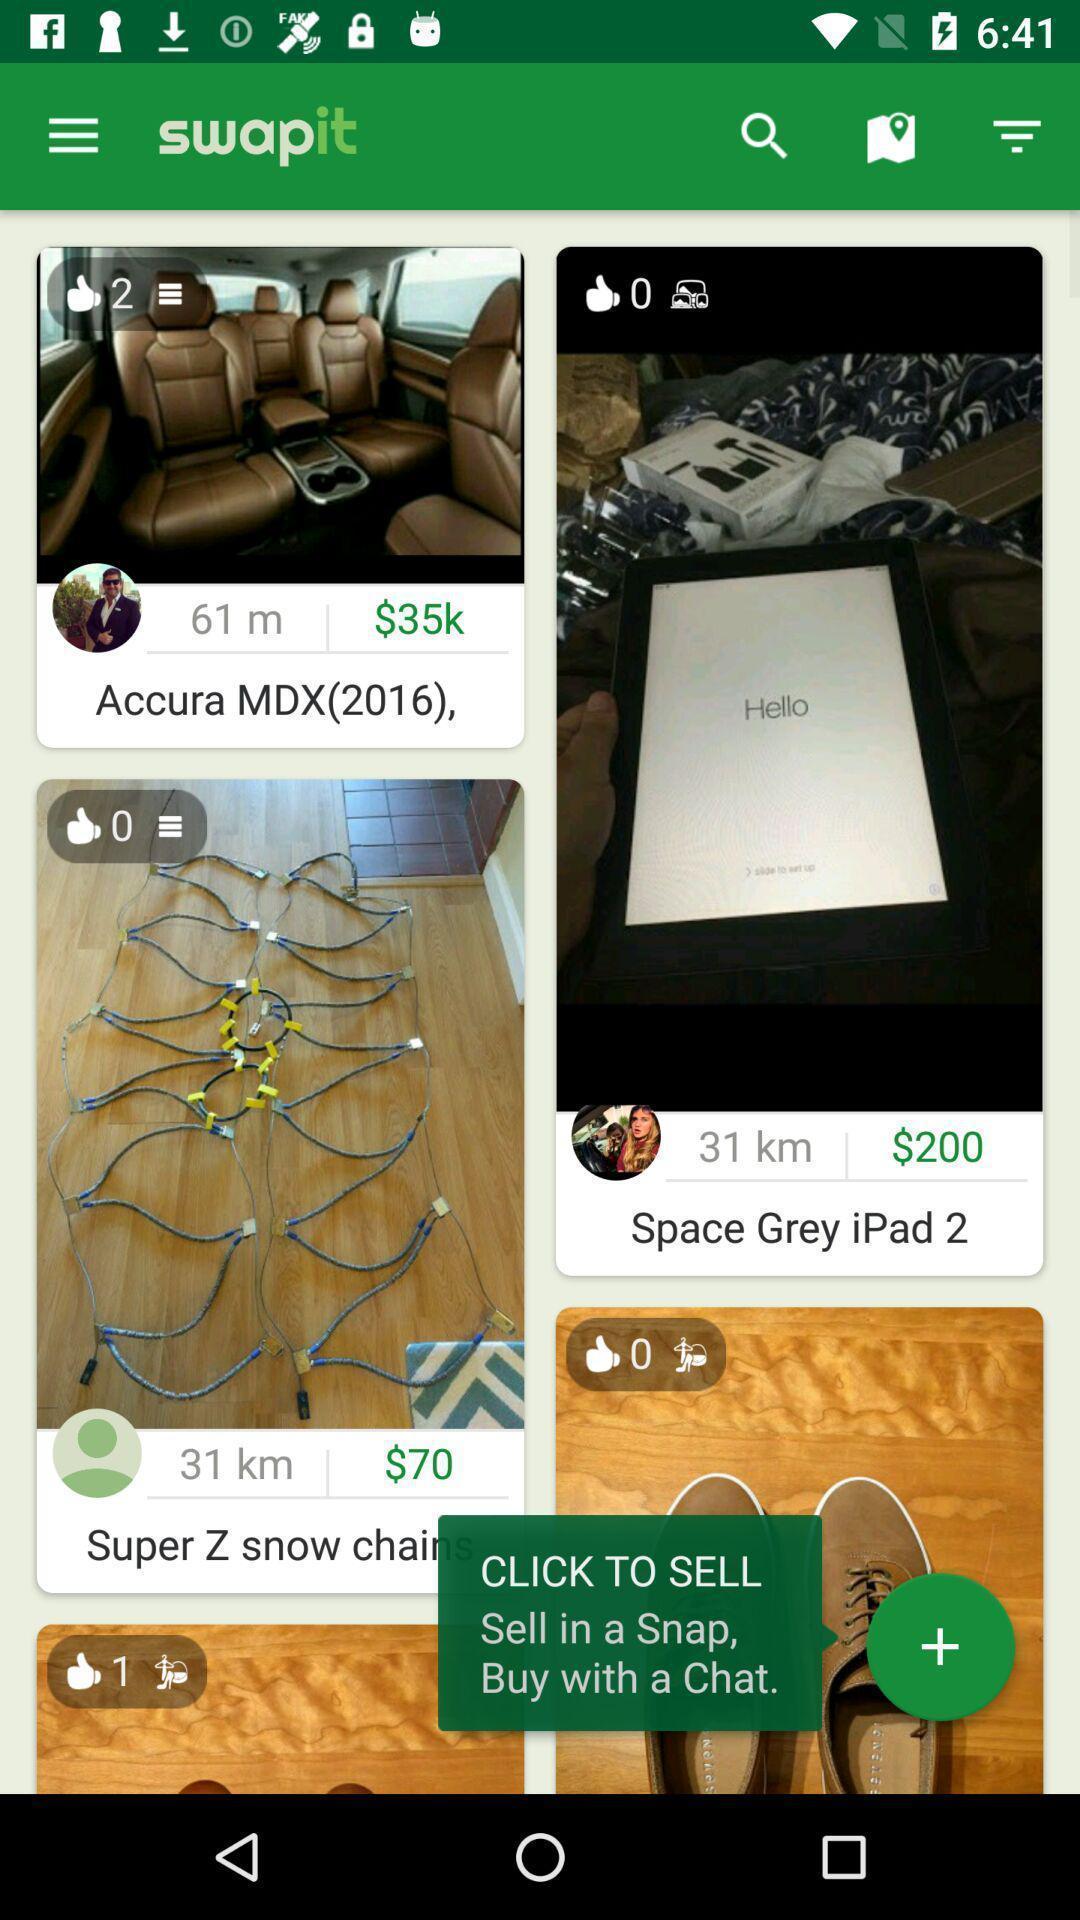Provide a detailed account of this screenshot. Page for sellers and buyers. 